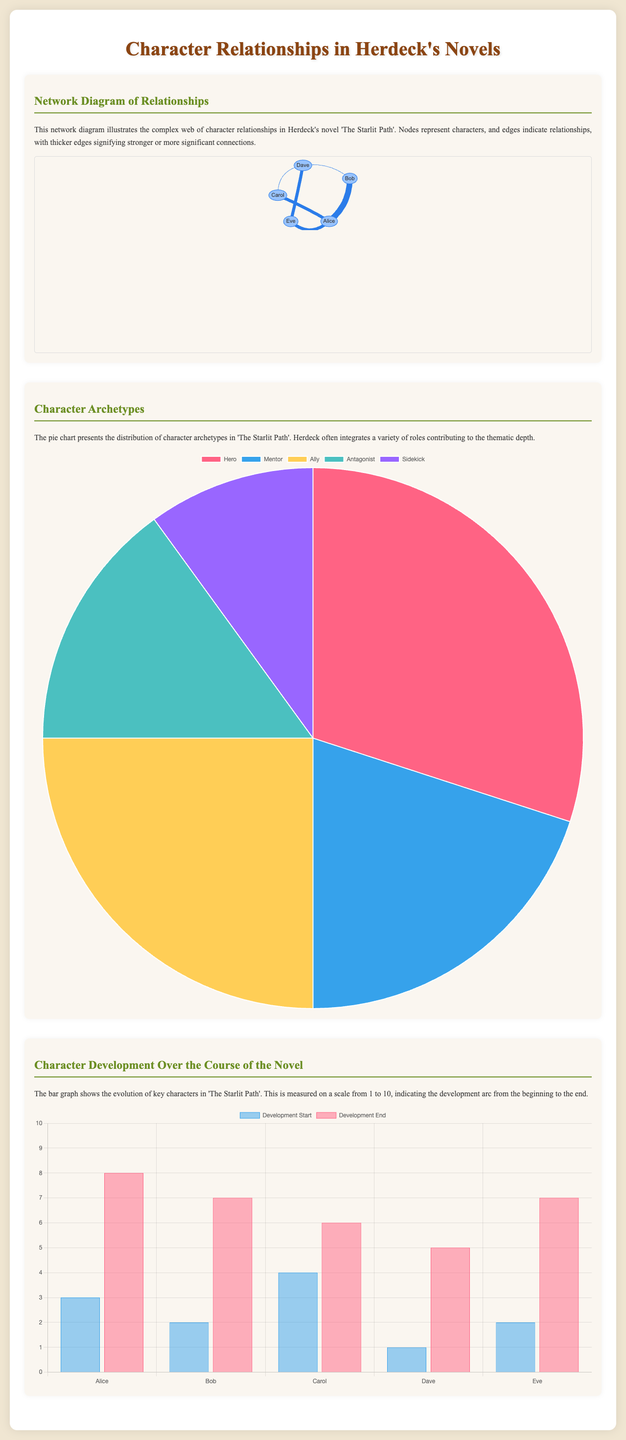What is the title of the infographic? The title is presented at the top of the document, indicating the focus on character relationships in a specific novel.
Answer: Character Relationships in Herdeck's Novels Which character has the highest developmental score at the end? The bar graph indicates the character's scores at the end of the development scale, where the highest value can be identified.
Answer: Alice What percentage of characters are heroes? The pie chart shows the distribution of character archetypes, including the percentage of heroes among them.
Answer: 30% Who is the antagonist character? The network diagram shows relationships among characters, and identifying the role titles can help determine the antagonist.
Answer: Not explicitly listed How many character archetypes are presented in total? The pie chart's segment labels provide information on the different character archetypes, indicating the total count listed in the chart.
Answer: Five Which two characters are most closely connected? The network diagram visually represents the strength of relationships through edge thickness, allowing for comparison of connections.
Answer: Alice and Bob What is the lowest development score at the start? The bar graph illustrates initial development scores, where the lowest value can be read directly from the graph.
Answer: 1 What is the range of character development scores? The bar graph provides scores for character development from the start to the end, and calculating this range provides specific values.
Answer: 7 Which character is categorized as a mentor in the pie chart? The pie chart distinguishes various character roles, and finding the relevant segment gives the character's title.
Answer: Not explicitly listed 